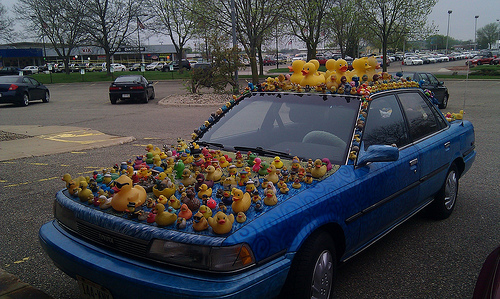<image>
Is there a rubber duck on the car? Yes. Looking at the image, I can see the rubber duck is positioned on top of the car, with the car providing support. Where is the car in relation to the flag? Is it above the flag? No. The car is not positioned above the flag. The vertical arrangement shows a different relationship. 